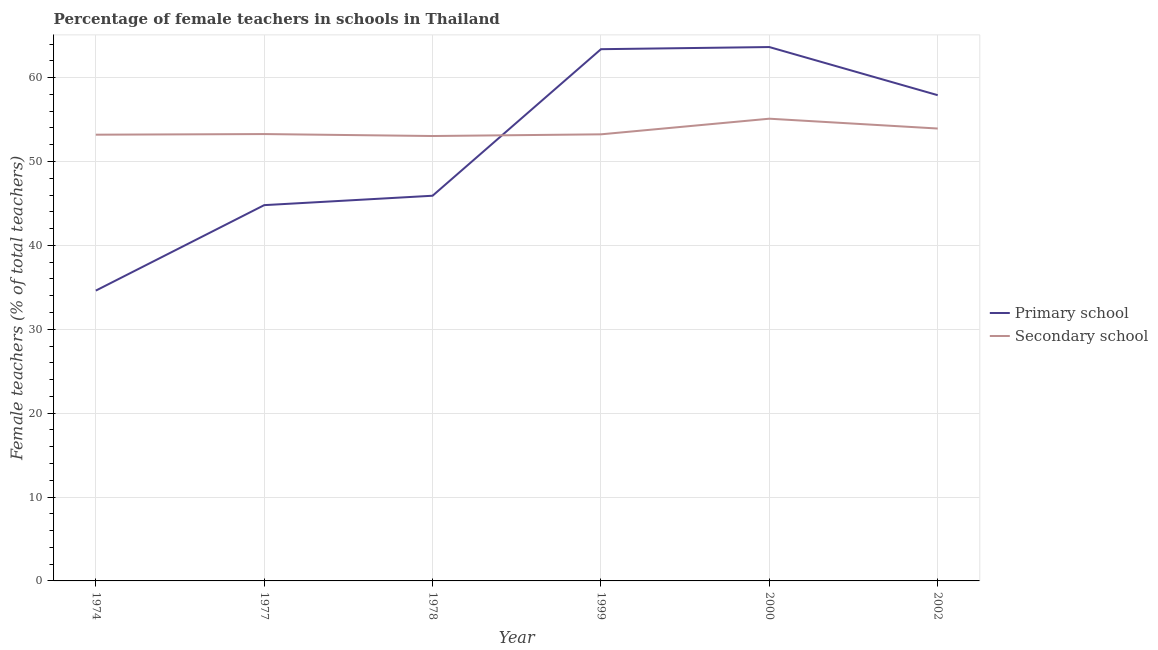Is the number of lines equal to the number of legend labels?
Give a very brief answer. Yes. What is the percentage of female teachers in secondary schools in 2000?
Your answer should be compact. 55.11. Across all years, what is the maximum percentage of female teachers in primary schools?
Provide a short and direct response. 63.65. Across all years, what is the minimum percentage of female teachers in primary schools?
Your answer should be compact. 34.61. In which year was the percentage of female teachers in primary schools maximum?
Provide a succinct answer. 2000. In which year was the percentage of female teachers in secondary schools minimum?
Your response must be concise. 1978. What is the total percentage of female teachers in secondary schools in the graph?
Make the answer very short. 321.8. What is the difference between the percentage of female teachers in secondary schools in 1978 and that in 2002?
Your response must be concise. -0.89. What is the difference between the percentage of female teachers in primary schools in 2002 and the percentage of female teachers in secondary schools in 2000?
Ensure brevity in your answer.  2.8. What is the average percentage of female teachers in secondary schools per year?
Offer a very short reply. 53.63. In the year 2000, what is the difference between the percentage of female teachers in primary schools and percentage of female teachers in secondary schools?
Ensure brevity in your answer.  8.54. What is the ratio of the percentage of female teachers in secondary schools in 1977 to that in 1999?
Your answer should be compact. 1. Is the percentage of female teachers in primary schools in 1974 less than that in 2000?
Give a very brief answer. Yes. Is the difference between the percentage of female teachers in primary schools in 1974 and 1977 greater than the difference between the percentage of female teachers in secondary schools in 1974 and 1977?
Offer a very short reply. No. What is the difference between the highest and the second highest percentage of female teachers in secondary schools?
Your answer should be compact. 1.17. What is the difference between the highest and the lowest percentage of female teachers in primary schools?
Provide a succinct answer. 29.04. Is the percentage of female teachers in secondary schools strictly less than the percentage of female teachers in primary schools over the years?
Ensure brevity in your answer.  No. Does the graph contain any zero values?
Offer a terse response. No. Does the graph contain grids?
Make the answer very short. Yes. How are the legend labels stacked?
Offer a very short reply. Vertical. What is the title of the graph?
Offer a terse response. Percentage of female teachers in schools in Thailand. What is the label or title of the X-axis?
Provide a short and direct response. Year. What is the label or title of the Y-axis?
Offer a terse response. Female teachers (% of total teachers). What is the Female teachers (% of total teachers) in Primary school in 1974?
Your response must be concise. 34.61. What is the Female teachers (% of total teachers) in Secondary school in 1974?
Provide a succinct answer. 53.2. What is the Female teachers (% of total teachers) of Primary school in 1977?
Your answer should be very brief. 44.8. What is the Female teachers (% of total teachers) of Secondary school in 1977?
Provide a short and direct response. 53.27. What is the Female teachers (% of total teachers) in Primary school in 1978?
Keep it short and to the point. 45.92. What is the Female teachers (% of total teachers) of Secondary school in 1978?
Make the answer very short. 53.04. What is the Female teachers (% of total teachers) in Primary school in 1999?
Make the answer very short. 63.39. What is the Female teachers (% of total teachers) in Secondary school in 1999?
Offer a very short reply. 53.24. What is the Female teachers (% of total teachers) in Primary school in 2000?
Keep it short and to the point. 63.65. What is the Female teachers (% of total teachers) in Secondary school in 2000?
Give a very brief answer. 55.11. What is the Female teachers (% of total teachers) of Primary school in 2002?
Offer a terse response. 57.91. What is the Female teachers (% of total teachers) of Secondary school in 2002?
Your response must be concise. 53.93. Across all years, what is the maximum Female teachers (% of total teachers) of Primary school?
Provide a short and direct response. 63.65. Across all years, what is the maximum Female teachers (% of total teachers) of Secondary school?
Provide a succinct answer. 55.11. Across all years, what is the minimum Female teachers (% of total teachers) in Primary school?
Keep it short and to the point. 34.61. Across all years, what is the minimum Female teachers (% of total teachers) of Secondary school?
Give a very brief answer. 53.04. What is the total Female teachers (% of total teachers) in Primary school in the graph?
Your answer should be very brief. 310.28. What is the total Female teachers (% of total teachers) of Secondary school in the graph?
Your response must be concise. 321.8. What is the difference between the Female teachers (% of total teachers) of Primary school in 1974 and that in 1977?
Your answer should be very brief. -10.19. What is the difference between the Female teachers (% of total teachers) in Secondary school in 1974 and that in 1977?
Your answer should be very brief. -0.07. What is the difference between the Female teachers (% of total teachers) of Primary school in 1974 and that in 1978?
Offer a very short reply. -11.31. What is the difference between the Female teachers (% of total teachers) in Secondary school in 1974 and that in 1978?
Offer a very short reply. 0.16. What is the difference between the Female teachers (% of total teachers) in Primary school in 1974 and that in 1999?
Ensure brevity in your answer.  -28.78. What is the difference between the Female teachers (% of total teachers) in Secondary school in 1974 and that in 1999?
Ensure brevity in your answer.  -0.04. What is the difference between the Female teachers (% of total teachers) in Primary school in 1974 and that in 2000?
Your answer should be very brief. -29.04. What is the difference between the Female teachers (% of total teachers) in Secondary school in 1974 and that in 2000?
Your answer should be very brief. -1.9. What is the difference between the Female teachers (% of total teachers) of Primary school in 1974 and that in 2002?
Your response must be concise. -23.3. What is the difference between the Female teachers (% of total teachers) in Secondary school in 1974 and that in 2002?
Provide a short and direct response. -0.73. What is the difference between the Female teachers (% of total teachers) of Primary school in 1977 and that in 1978?
Ensure brevity in your answer.  -1.12. What is the difference between the Female teachers (% of total teachers) in Secondary school in 1977 and that in 1978?
Ensure brevity in your answer.  0.23. What is the difference between the Female teachers (% of total teachers) of Primary school in 1977 and that in 1999?
Your response must be concise. -18.59. What is the difference between the Female teachers (% of total teachers) in Secondary school in 1977 and that in 1999?
Your response must be concise. 0.03. What is the difference between the Female teachers (% of total teachers) in Primary school in 1977 and that in 2000?
Provide a short and direct response. -18.85. What is the difference between the Female teachers (% of total teachers) of Secondary school in 1977 and that in 2000?
Your response must be concise. -1.83. What is the difference between the Female teachers (% of total teachers) of Primary school in 1977 and that in 2002?
Give a very brief answer. -13.11. What is the difference between the Female teachers (% of total teachers) of Secondary school in 1977 and that in 2002?
Provide a short and direct response. -0.66. What is the difference between the Female teachers (% of total teachers) in Primary school in 1978 and that in 1999?
Provide a succinct answer. -17.47. What is the difference between the Female teachers (% of total teachers) of Secondary school in 1978 and that in 1999?
Give a very brief answer. -0.2. What is the difference between the Female teachers (% of total teachers) in Primary school in 1978 and that in 2000?
Your answer should be compact. -17.73. What is the difference between the Female teachers (% of total teachers) in Secondary school in 1978 and that in 2000?
Provide a short and direct response. -2.06. What is the difference between the Female teachers (% of total teachers) of Primary school in 1978 and that in 2002?
Keep it short and to the point. -11.99. What is the difference between the Female teachers (% of total teachers) of Secondary school in 1978 and that in 2002?
Make the answer very short. -0.89. What is the difference between the Female teachers (% of total teachers) in Primary school in 1999 and that in 2000?
Make the answer very short. -0.25. What is the difference between the Female teachers (% of total teachers) in Secondary school in 1999 and that in 2000?
Offer a very short reply. -1.86. What is the difference between the Female teachers (% of total teachers) in Primary school in 1999 and that in 2002?
Offer a terse response. 5.48. What is the difference between the Female teachers (% of total teachers) in Secondary school in 1999 and that in 2002?
Ensure brevity in your answer.  -0.69. What is the difference between the Female teachers (% of total teachers) of Primary school in 2000 and that in 2002?
Keep it short and to the point. 5.74. What is the difference between the Female teachers (% of total teachers) of Secondary school in 2000 and that in 2002?
Provide a succinct answer. 1.17. What is the difference between the Female teachers (% of total teachers) in Primary school in 1974 and the Female teachers (% of total teachers) in Secondary school in 1977?
Provide a succinct answer. -18.66. What is the difference between the Female teachers (% of total teachers) of Primary school in 1974 and the Female teachers (% of total teachers) of Secondary school in 1978?
Provide a short and direct response. -18.43. What is the difference between the Female teachers (% of total teachers) in Primary school in 1974 and the Female teachers (% of total teachers) in Secondary school in 1999?
Make the answer very short. -18.63. What is the difference between the Female teachers (% of total teachers) in Primary school in 1974 and the Female teachers (% of total teachers) in Secondary school in 2000?
Your answer should be very brief. -20.49. What is the difference between the Female teachers (% of total teachers) in Primary school in 1974 and the Female teachers (% of total teachers) in Secondary school in 2002?
Keep it short and to the point. -19.32. What is the difference between the Female teachers (% of total teachers) of Primary school in 1977 and the Female teachers (% of total teachers) of Secondary school in 1978?
Ensure brevity in your answer.  -8.24. What is the difference between the Female teachers (% of total teachers) of Primary school in 1977 and the Female teachers (% of total teachers) of Secondary school in 1999?
Offer a terse response. -8.44. What is the difference between the Female teachers (% of total teachers) of Primary school in 1977 and the Female teachers (% of total teachers) of Secondary school in 2000?
Provide a short and direct response. -10.3. What is the difference between the Female teachers (% of total teachers) of Primary school in 1977 and the Female teachers (% of total teachers) of Secondary school in 2002?
Your answer should be very brief. -9.13. What is the difference between the Female teachers (% of total teachers) of Primary school in 1978 and the Female teachers (% of total teachers) of Secondary school in 1999?
Offer a very short reply. -7.32. What is the difference between the Female teachers (% of total teachers) of Primary school in 1978 and the Female teachers (% of total teachers) of Secondary school in 2000?
Your answer should be very brief. -9.18. What is the difference between the Female teachers (% of total teachers) of Primary school in 1978 and the Female teachers (% of total teachers) of Secondary school in 2002?
Make the answer very short. -8.01. What is the difference between the Female teachers (% of total teachers) in Primary school in 1999 and the Female teachers (% of total teachers) in Secondary school in 2000?
Provide a short and direct response. 8.29. What is the difference between the Female teachers (% of total teachers) of Primary school in 1999 and the Female teachers (% of total teachers) of Secondary school in 2002?
Ensure brevity in your answer.  9.46. What is the difference between the Female teachers (% of total teachers) of Primary school in 2000 and the Female teachers (% of total teachers) of Secondary school in 2002?
Provide a short and direct response. 9.71. What is the average Female teachers (% of total teachers) in Primary school per year?
Ensure brevity in your answer.  51.71. What is the average Female teachers (% of total teachers) of Secondary school per year?
Provide a succinct answer. 53.63. In the year 1974, what is the difference between the Female teachers (% of total teachers) in Primary school and Female teachers (% of total teachers) in Secondary school?
Provide a short and direct response. -18.59. In the year 1977, what is the difference between the Female teachers (% of total teachers) in Primary school and Female teachers (% of total teachers) in Secondary school?
Keep it short and to the point. -8.47. In the year 1978, what is the difference between the Female teachers (% of total teachers) in Primary school and Female teachers (% of total teachers) in Secondary school?
Provide a succinct answer. -7.12. In the year 1999, what is the difference between the Female teachers (% of total teachers) in Primary school and Female teachers (% of total teachers) in Secondary school?
Ensure brevity in your answer.  10.15. In the year 2000, what is the difference between the Female teachers (% of total teachers) in Primary school and Female teachers (% of total teachers) in Secondary school?
Provide a short and direct response. 8.54. In the year 2002, what is the difference between the Female teachers (% of total teachers) in Primary school and Female teachers (% of total teachers) in Secondary school?
Make the answer very short. 3.98. What is the ratio of the Female teachers (% of total teachers) in Primary school in 1974 to that in 1977?
Offer a terse response. 0.77. What is the ratio of the Female teachers (% of total teachers) of Secondary school in 1974 to that in 1977?
Make the answer very short. 1. What is the ratio of the Female teachers (% of total teachers) of Primary school in 1974 to that in 1978?
Provide a succinct answer. 0.75. What is the ratio of the Female teachers (% of total teachers) of Secondary school in 1974 to that in 1978?
Your answer should be compact. 1. What is the ratio of the Female teachers (% of total teachers) of Primary school in 1974 to that in 1999?
Provide a short and direct response. 0.55. What is the ratio of the Female teachers (% of total teachers) in Secondary school in 1974 to that in 1999?
Give a very brief answer. 1. What is the ratio of the Female teachers (% of total teachers) in Primary school in 1974 to that in 2000?
Your response must be concise. 0.54. What is the ratio of the Female teachers (% of total teachers) of Secondary school in 1974 to that in 2000?
Your answer should be very brief. 0.97. What is the ratio of the Female teachers (% of total teachers) in Primary school in 1974 to that in 2002?
Provide a short and direct response. 0.6. What is the ratio of the Female teachers (% of total teachers) in Secondary school in 1974 to that in 2002?
Keep it short and to the point. 0.99. What is the ratio of the Female teachers (% of total teachers) of Primary school in 1977 to that in 1978?
Offer a terse response. 0.98. What is the ratio of the Female teachers (% of total teachers) in Primary school in 1977 to that in 1999?
Ensure brevity in your answer.  0.71. What is the ratio of the Female teachers (% of total teachers) in Secondary school in 1977 to that in 1999?
Your answer should be very brief. 1. What is the ratio of the Female teachers (% of total teachers) in Primary school in 1977 to that in 2000?
Make the answer very short. 0.7. What is the ratio of the Female teachers (% of total teachers) of Secondary school in 1977 to that in 2000?
Provide a short and direct response. 0.97. What is the ratio of the Female teachers (% of total teachers) in Primary school in 1977 to that in 2002?
Your response must be concise. 0.77. What is the ratio of the Female teachers (% of total teachers) of Secondary school in 1977 to that in 2002?
Give a very brief answer. 0.99. What is the ratio of the Female teachers (% of total teachers) in Primary school in 1978 to that in 1999?
Your response must be concise. 0.72. What is the ratio of the Female teachers (% of total teachers) of Secondary school in 1978 to that in 1999?
Provide a succinct answer. 1. What is the ratio of the Female teachers (% of total teachers) in Primary school in 1978 to that in 2000?
Provide a succinct answer. 0.72. What is the ratio of the Female teachers (% of total teachers) in Secondary school in 1978 to that in 2000?
Give a very brief answer. 0.96. What is the ratio of the Female teachers (% of total teachers) of Primary school in 1978 to that in 2002?
Offer a terse response. 0.79. What is the ratio of the Female teachers (% of total teachers) in Secondary school in 1978 to that in 2002?
Offer a very short reply. 0.98. What is the ratio of the Female teachers (% of total teachers) in Secondary school in 1999 to that in 2000?
Make the answer very short. 0.97. What is the ratio of the Female teachers (% of total teachers) in Primary school in 1999 to that in 2002?
Provide a succinct answer. 1.09. What is the ratio of the Female teachers (% of total teachers) of Secondary school in 1999 to that in 2002?
Ensure brevity in your answer.  0.99. What is the ratio of the Female teachers (% of total teachers) of Primary school in 2000 to that in 2002?
Offer a terse response. 1.1. What is the ratio of the Female teachers (% of total teachers) in Secondary school in 2000 to that in 2002?
Provide a short and direct response. 1.02. What is the difference between the highest and the second highest Female teachers (% of total teachers) of Primary school?
Offer a very short reply. 0.25. What is the difference between the highest and the second highest Female teachers (% of total teachers) in Secondary school?
Provide a succinct answer. 1.17. What is the difference between the highest and the lowest Female teachers (% of total teachers) of Primary school?
Provide a short and direct response. 29.04. What is the difference between the highest and the lowest Female teachers (% of total teachers) of Secondary school?
Offer a terse response. 2.06. 